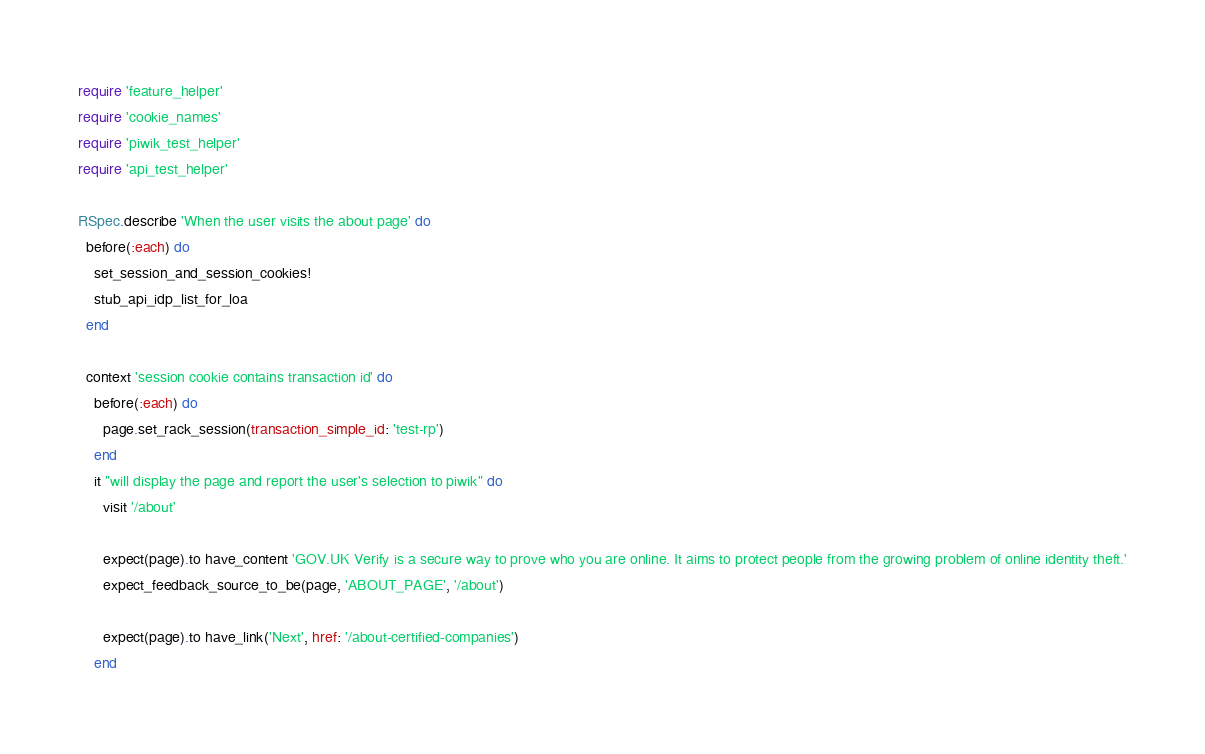<code> <loc_0><loc_0><loc_500><loc_500><_Ruby_>require 'feature_helper'
require 'cookie_names'
require 'piwik_test_helper'
require 'api_test_helper'

RSpec.describe 'When the user visits the about page' do
  before(:each) do
    set_session_and_session_cookies!
    stub_api_idp_list_for_loa
  end

  context 'session cookie contains transaction id' do
    before(:each) do
      page.set_rack_session(transaction_simple_id: 'test-rp')
    end
    it "will display the page and report the user's selection to piwik" do
      visit '/about'

      expect(page).to have_content 'GOV.UK Verify is a secure way to prove who you are online. It aims to protect people from the growing problem of online identity theft.'
      expect_feedback_source_to_be(page, 'ABOUT_PAGE', '/about')

      expect(page).to have_link('Next', href: '/about-certified-companies')
    end
</code> 